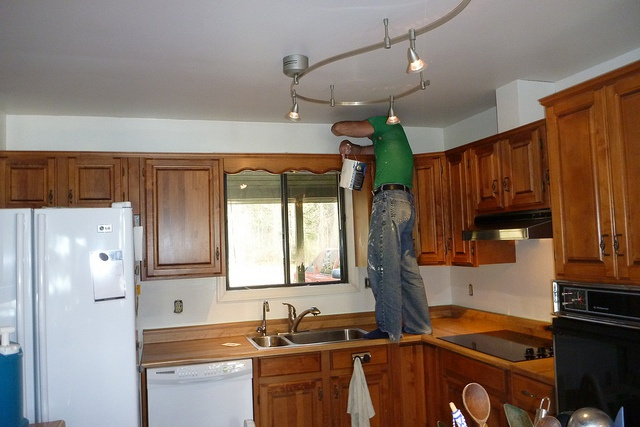Describe the objects in this image and their specific colors. I can see refrigerator in gray, lightgray, and darkgray tones, people in gray, black, and darkgreen tones, oven in gray, black, and maroon tones, car in gray, lightgray, tan, and darkgray tones, and spoon in gray, brown, maroon, and tan tones in this image. 